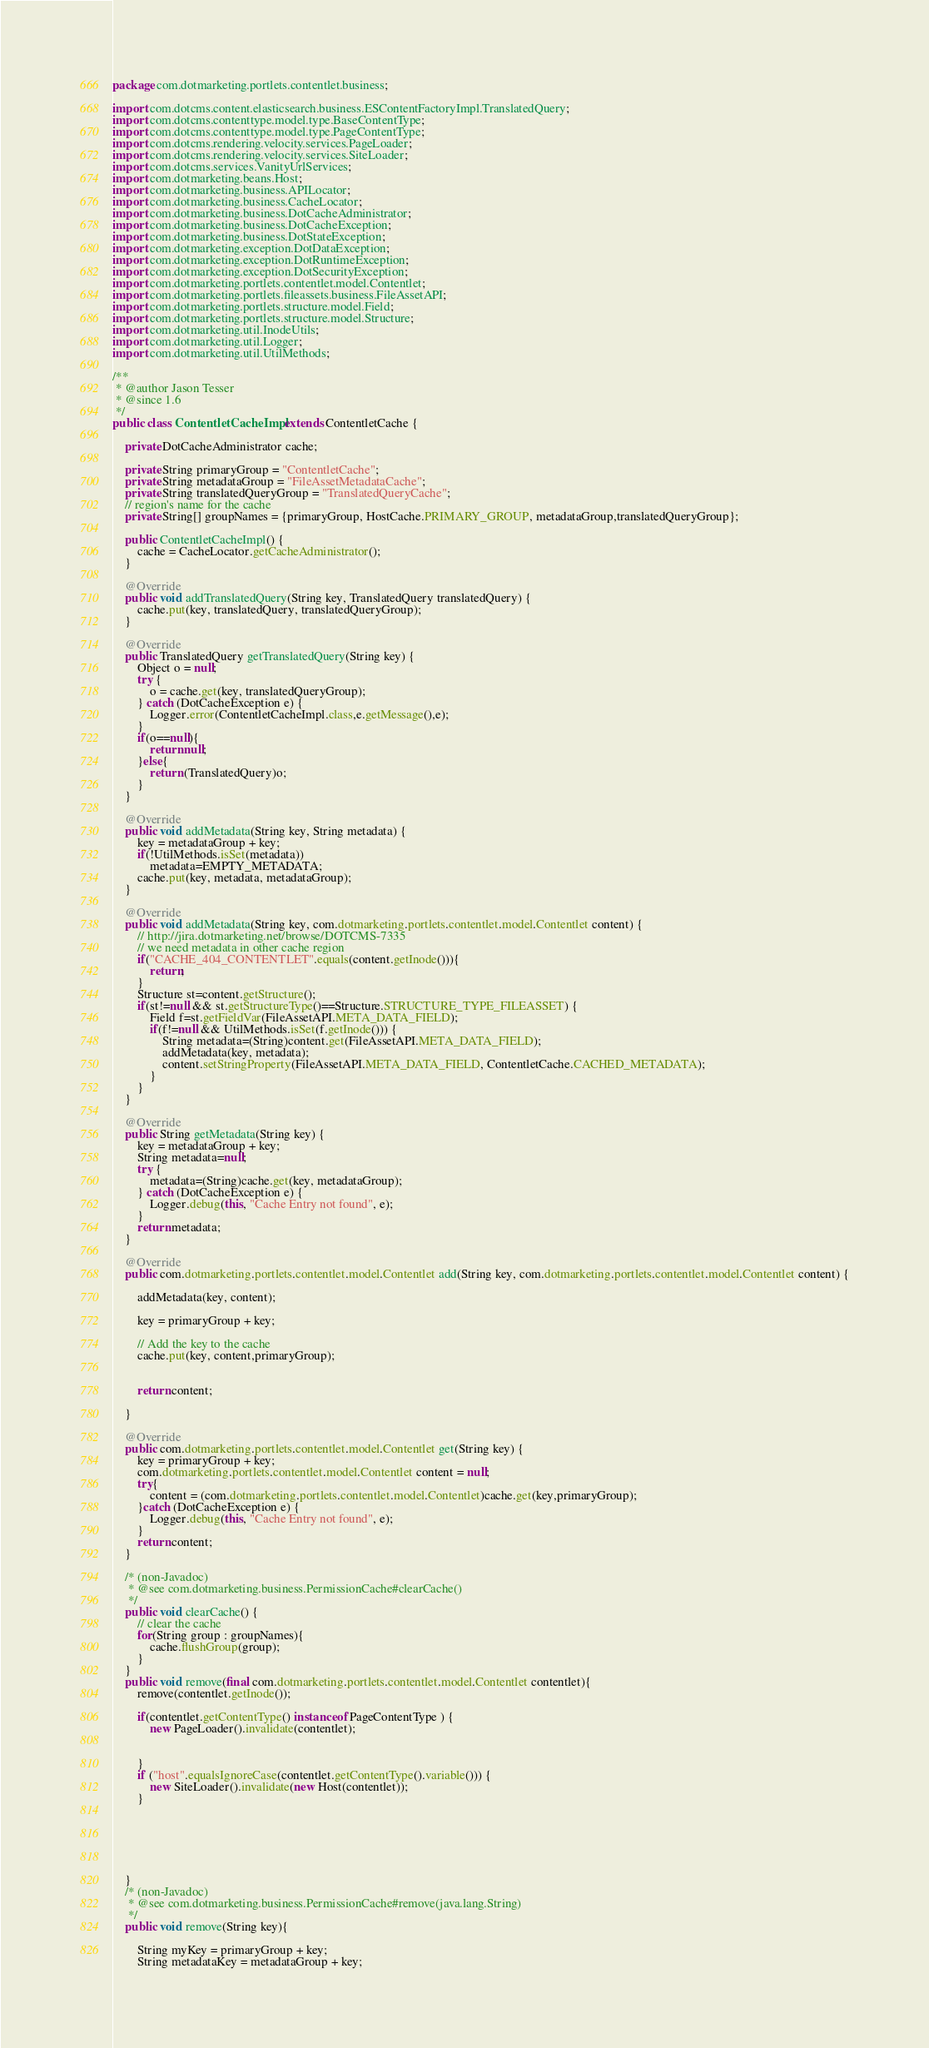Convert code to text. <code><loc_0><loc_0><loc_500><loc_500><_Java_>package com.dotmarketing.portlets.contentlet.business;

import com.dotcms.content.elasticsearch.business.ESContentFactoryImpl.TranslatedQuery;
import com.dotcms.contenttype.model.type.BaseContentType;
import com.dotcms.contenttype.model.type.PageContentType;
import com.dotcms.rendering.velocity.services.PageLoader;
import com.dotcms.rendering.velocity.services.SiteLoader;
import com.dotcms.services.VanityUrlServices;
import com.dotmarketing.beans.Host;
import com.dotmarketing.business.APILocator;
import com.dotmarketing.business.CacheLocator;
import com.dotmarketing.business.DotCacheAdministrator;
import com.dotmarketing.business.DotCacheException;
import com.dotmarketing.business.DotStateException;
import com.dotmarketing.exception.DotDataException;
import com.dotmarketing.exception.DotRuntimeException;
import com.dotmarketing.exception.DotSecurityException;
import com.dotmarketing.portlets.contentlet.model.Contentlet;
import com.dotmarketing.portlets.fileassets.business.FileAssetAPI;
import com.dotmarketing.portlets.structure.model.Field;
import com.dotmarketing.portlets.structure.model.Structure;
import com.dotmarketing.util.InodeUtils;
import com.dotmarketing.util.Logger;
import com.dotmarketing.util.UtilMethods;

/**
 * @author Jason Tesser
 * @since 1.6
 */
public class ContentletCacheImpl extends ContentletCache {

	private DotCacheAdministrator cache;

	private String primaryGroup = "ContentletCache";
	private String metadataGroup = "FileAssetMetadataCache";
	private String translatedQueryGroup = "TranslatedQueryCache";
	// region's name for the cache
	private String[] groupNames = {primaryGroup, HostCache.PRIMARY_GROUP, metadataGroup,translatedQueryGroup};

	public ContentletCacheImpl() {
		cache = CacheLocator.getCacheAdministrator();
	}

	@Override
	public void addTranslatedQuery(String key, TranslatedQuery translatedQuery) {
		cache.put(key, translatedQuery, translatedQueryGroup);
	}

	@Override
	public TranslatedQuery getTranslatedQuery(String key) {
		Object o = null;
		try {
			o = cache.get(key, translatedQueryGroup);
		} catch (DotCacheException e) {
			Logger.error(ContentletCacheImpl.class,e.getMessage(),e);
		}
		if(o==null){
			return null;
		}else{
			return (TranslatedQuery)o;
		}
	}

	@Override
	public void addMetadata(String key, String metadata) {
		key = metadataGroup + key;
		if(!UtilMethods.isSet(metadata))
			metadata=EMPTY_METADATA;
		cache.put(key, metadata, metadataGroup);
	}

	@Override
	public void addMetadata(String key, com.dotmarketing.portlets.contentlet.model.Contentlet content) {
		// http://jira.dotmarketing.net/browse/DOTCMS-7335
		// we need metadata in other cache region
		if("CACHE_404_CONTENTLET".equals(content.getInode())){
			return;
		}
		Structure st=content.getStructure();
		if(st!=null && st.getStructureType()==Structure.STRUCTURE_TYPE_FILEASSET) {
			Field f=st.getFieldVar(FileAssetAPI.META_DATA_FIELD);
			if(f!=null && UtilMethods.isSet(f.getInode())) {
				String metadata=(String)content.get(FileAssetAPI.META_DATA_FIELD);
				addMetadata(key, metadata);
				content.setStringProperty(FileAssetAPI.META_DATA_FIELD, ContentletCache.CACHED_METADATA);
			}
		}
	}

	@Override
	public String getMetadata(String key) {
		key = metadataGroup + key;
		String metadata=null;
		try {
			metadata=(String)cache.get(key, metadataGroup);
		} catch (DotCacheException e) {
			Logger.debug(this, "Cache Entry not found", e);
		}
		return metadata;
	}

	@Override
	public com.dotmarketing.portlets.contentlet.model.Contentlet add(String key, com.dotmarketing.portlets.contentlet.model.Contentlet content) {

		addMetadata(key, content);

		key = primaryGroup + key;

		// Add the key to the cache
		cache.put(key, content,primaryGroup);


		return content;

	}

	@Override
	public com.dotmarketing.portlets.contentlet.model.Contentlet get(String key) {
		key = primaryGroup + key;
		com.dotmarketing.portlets.contentlet.model.Contentlet content = null;
		try{
			content = (com.dotmarketing.portlets.contentlet.model.Contentlet)cache.get(key,primaryGroup);
		}catch (DotCacheException e) {
			Logger.debug(this, "Cache Entry not found", e);
		}
		return content;
	}

	/* (non-Javadoc)
     * @see com.dotmarketing.business.PermissionCache#clearCache()
     */
	public void clearCache() {
		// clear the cache
		for(String group : groupNames){
			cache.flushGroup(group);
		}
	}
    public void remove(final com.dotmarketing.portlets.contentlet.model.Contentlet contentlet){
        remove(contentlet.getInode());

        if(contentlet.getContentType() instanceof PageContentType ) {
            new PageLoader().invalidate(contentlet);
            
            
        }
        if ("host".equalsIgnoreCase(contentlet.getContentType().variable())) {
            new SiteLoader().invalidate(new Host(contentlet));
        }
            

        
        
        
        
    }
	/* (non-Javadoc)
     * @see com.dotmarketing.business.PermissionCache#remove(java.lang.String)
     */
	public void remove(String key){

		String myKey = primaryGroup + key;
		String metadataKey = metadataGroup + key;</code> 